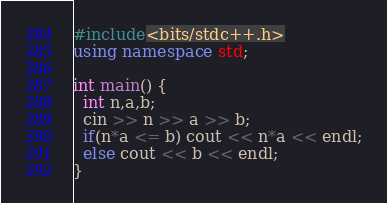<code> <loc_0><loc_0><loc_500><loc_500><_C++_>#include<bits/stdc++.h>
using namespace std;

int main() {
  int n,a,b;
  cin >> n >> a >> b;
  if(n*a <= b) cout << n*a << endl;
  else cout << b << endl;
}</code> 